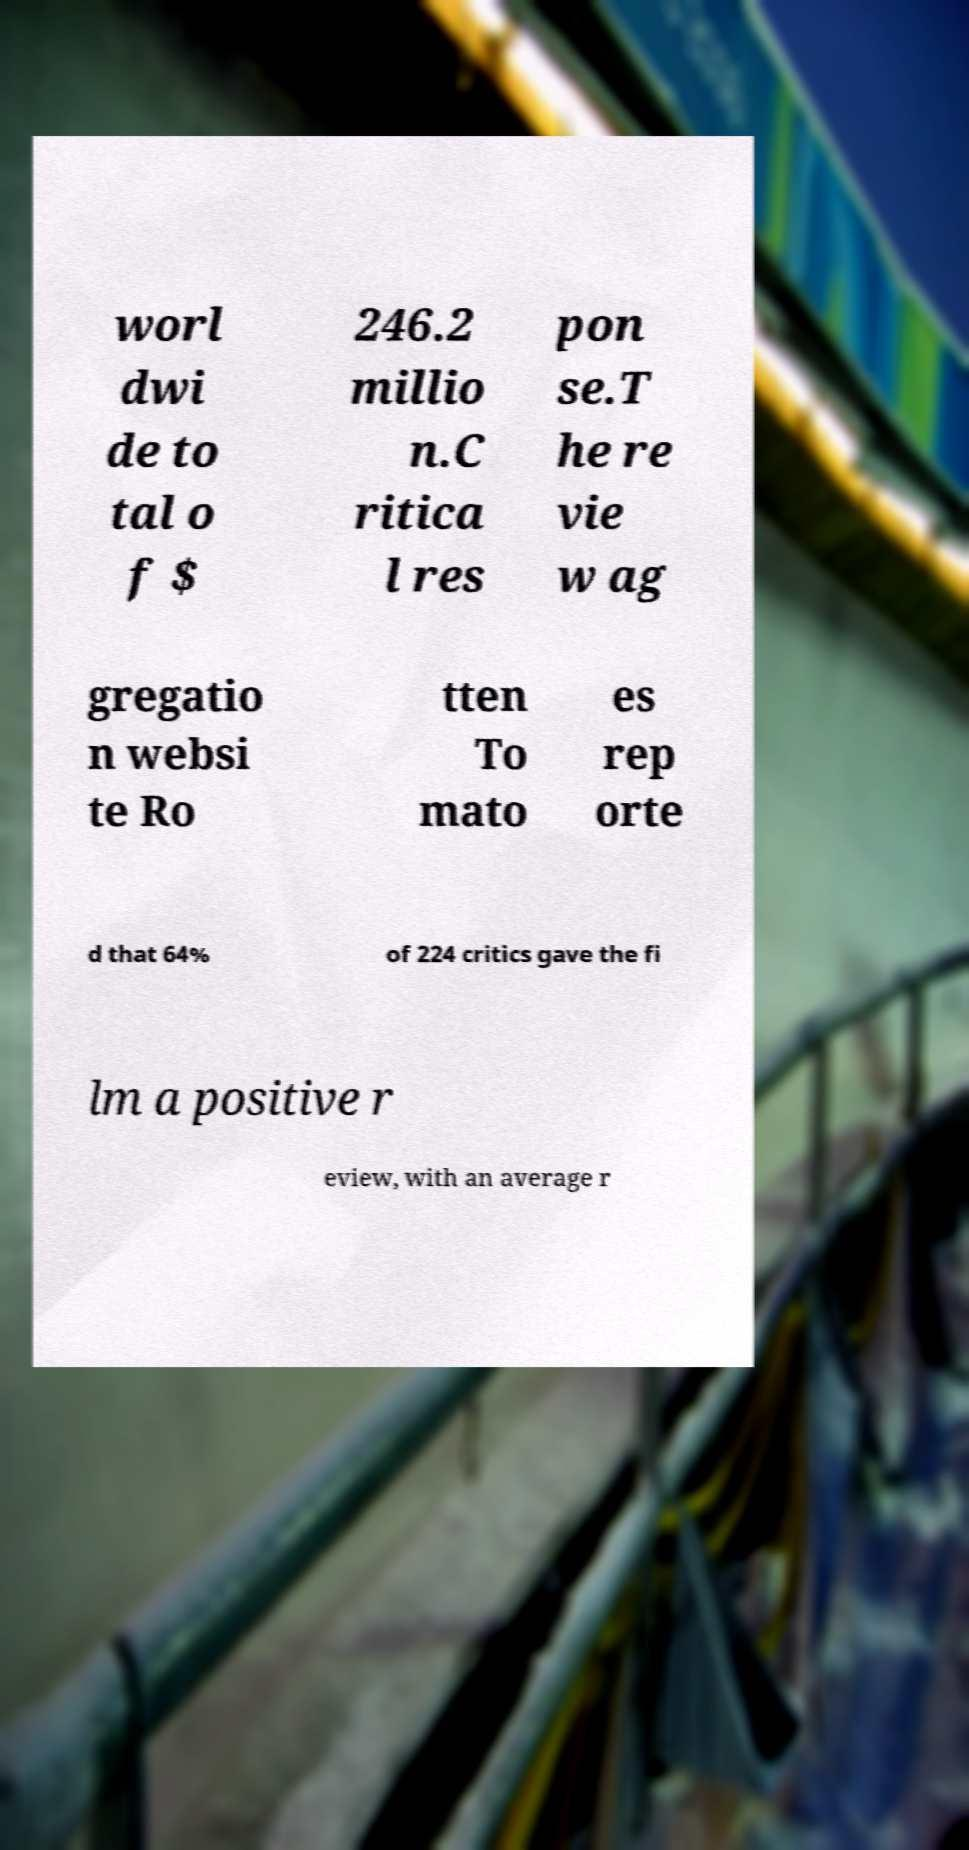Please identify and transcribe the text found in this image. worl dwi de to tal o f $ 246.2 millio n.C ritica l res pon se.T he re vie w ag gregatio n websi te Ro tten To mato es rep orte d that 64% of 224 critics gave the fi lm a positive r eview, with an average r 